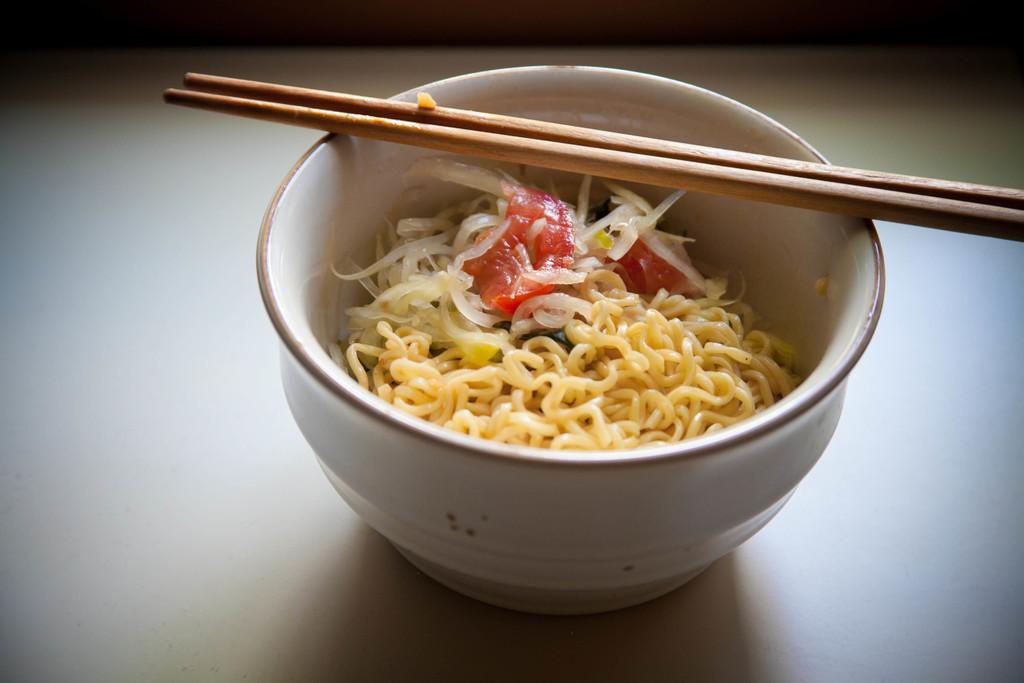What is in the bowl that is visible in the image? There is a bowl in the image, and it contains noodles and tomatoes. What utensils are visible in the image? Chopsticks are visible in the image. What type of food is in the bowl? The bowl contains noodles and tomatoes, which suggests it might be a noodle dish. What type of brick is used to build the wall in the image? There is no wall or brick present in the image; it features a bowl with noodles and tomatoes, along with chopsticks. 